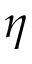<formula> <loc_0><loc_0><loc_500><loc_500>\eta</formula> 